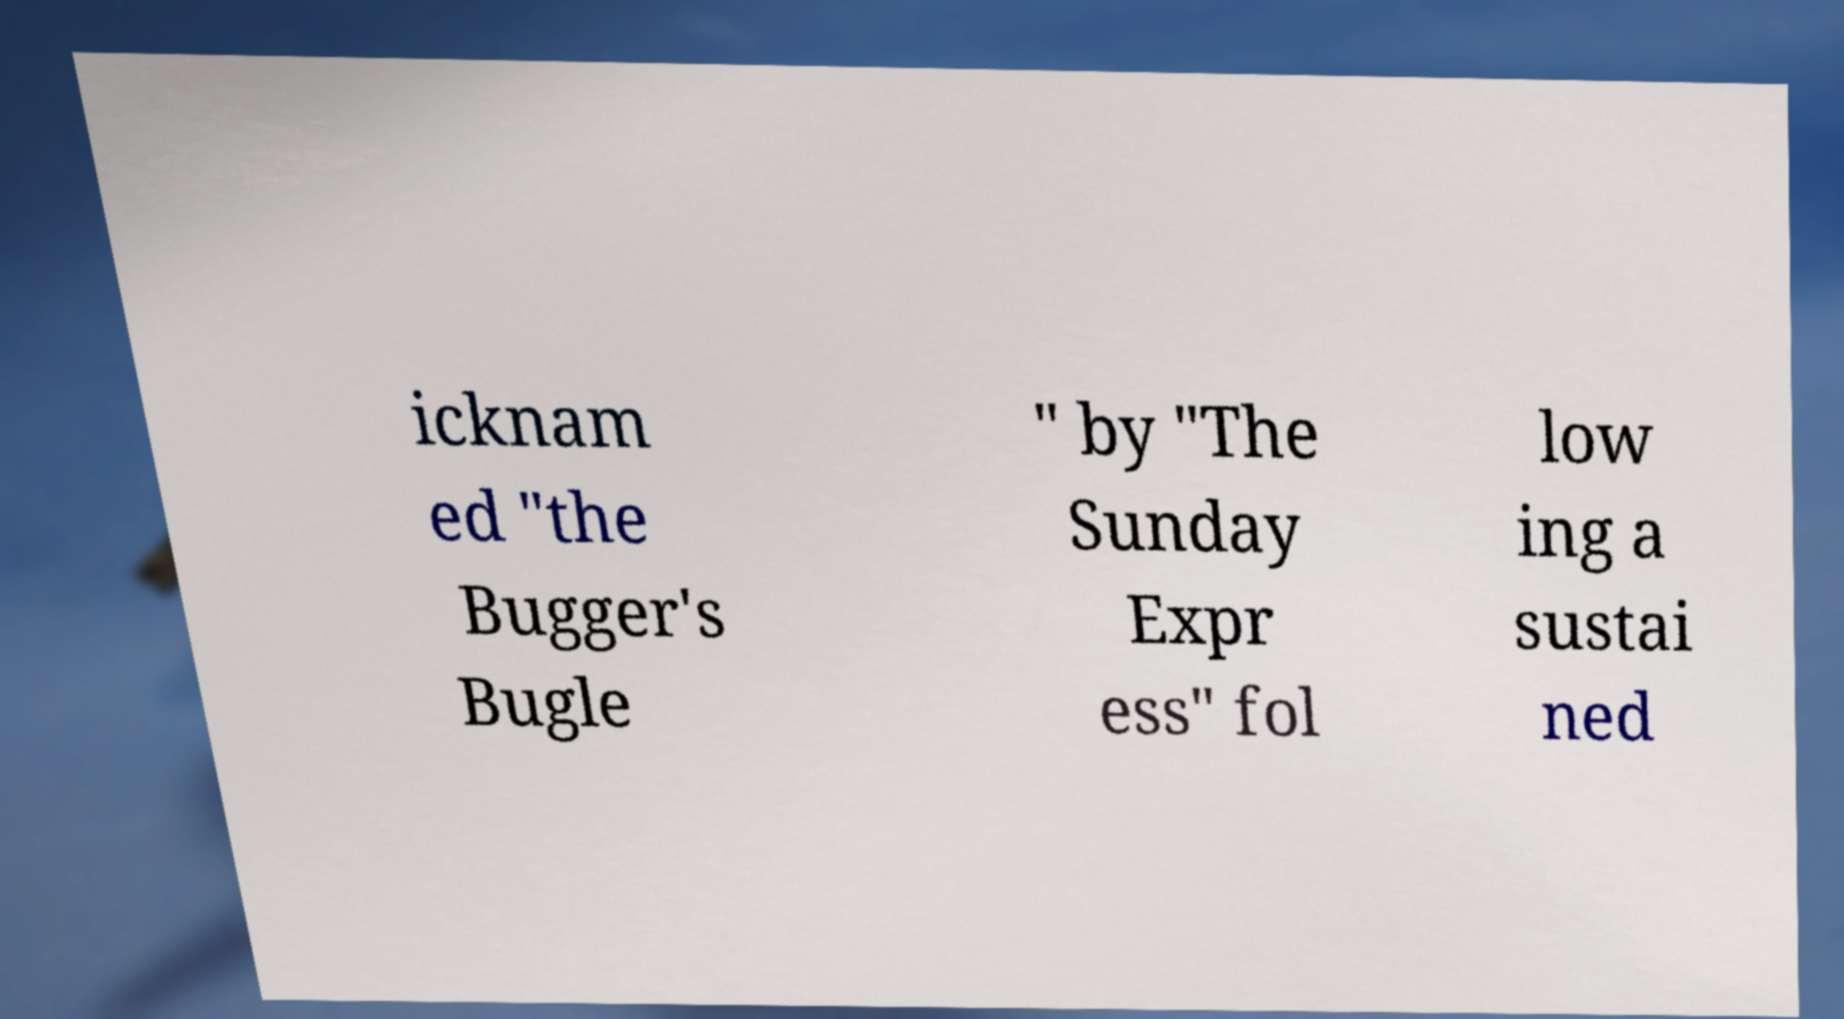Please identify and transcribe the text found in this image. icknam ed "the Bugger's Bugle " by "The Sunday Expr ess" fol low ing a sustai ned 